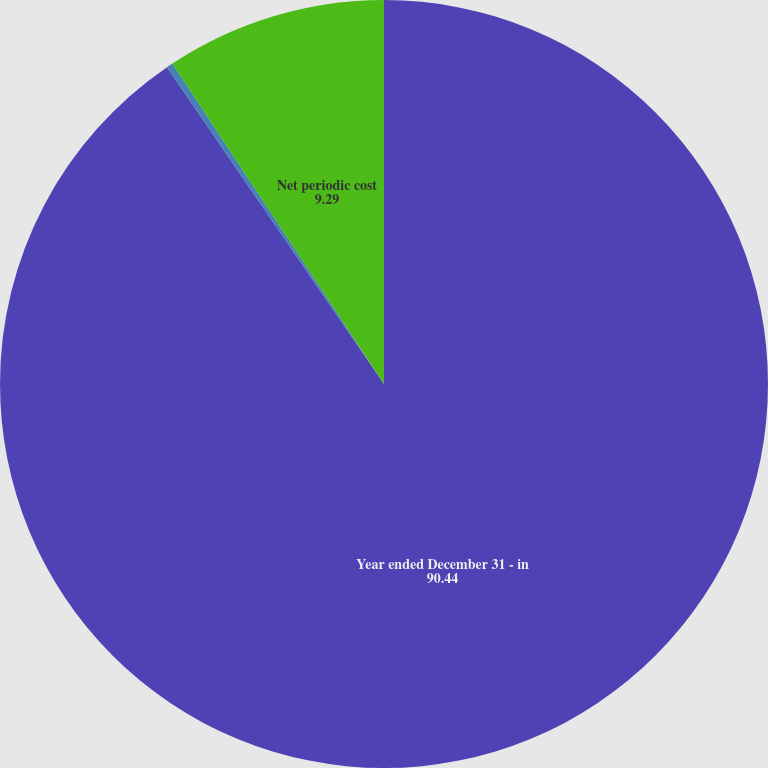Convert chart to OTSL. <chart><loc_0><loc_0><loc_500><loc_500><pie_chart><fcel>Year ended December 31 - in<fcel>Interest cost<fcel>Net periodic cost<nl><fcel>90.44%<fcel>0.27%<fcel>9.29%<nl></chart> 